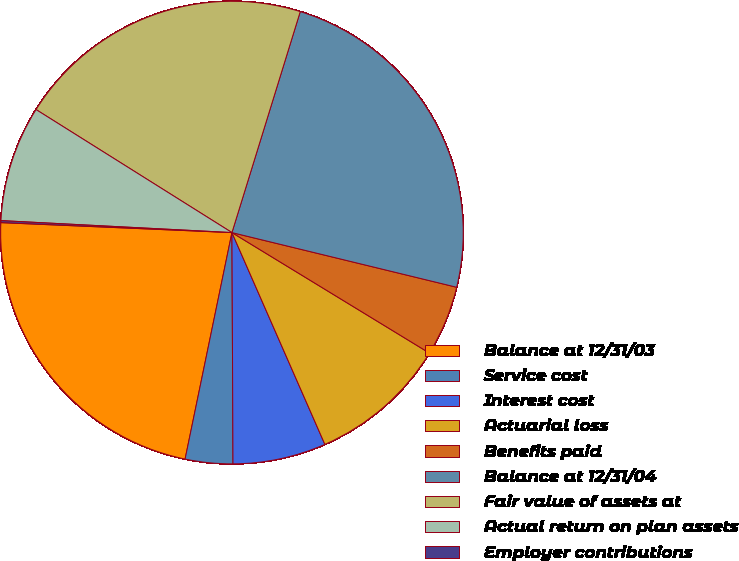<chart> <loc_0><loc_0><loc_500><loc_500><pie_chart><fcel>Balance at 12/31/03<fcel>Service cost<fcel>Interest cost<fcel>Actuarial loss<fcel>Benefits paid<fcel>Balance at 12/31/04<fcel>Fair value of assets at<fcel>Actual return on plan assets<fcel>Employer contributions<nl><fcel>22.44%<fcel>3.32%<fcel>6.51%<fcel>9.7%<fcel>4.92%<fcel>24.03%<fcel>20.85%<fcel>8.1%<fcel>0.14%<nl></chart> 